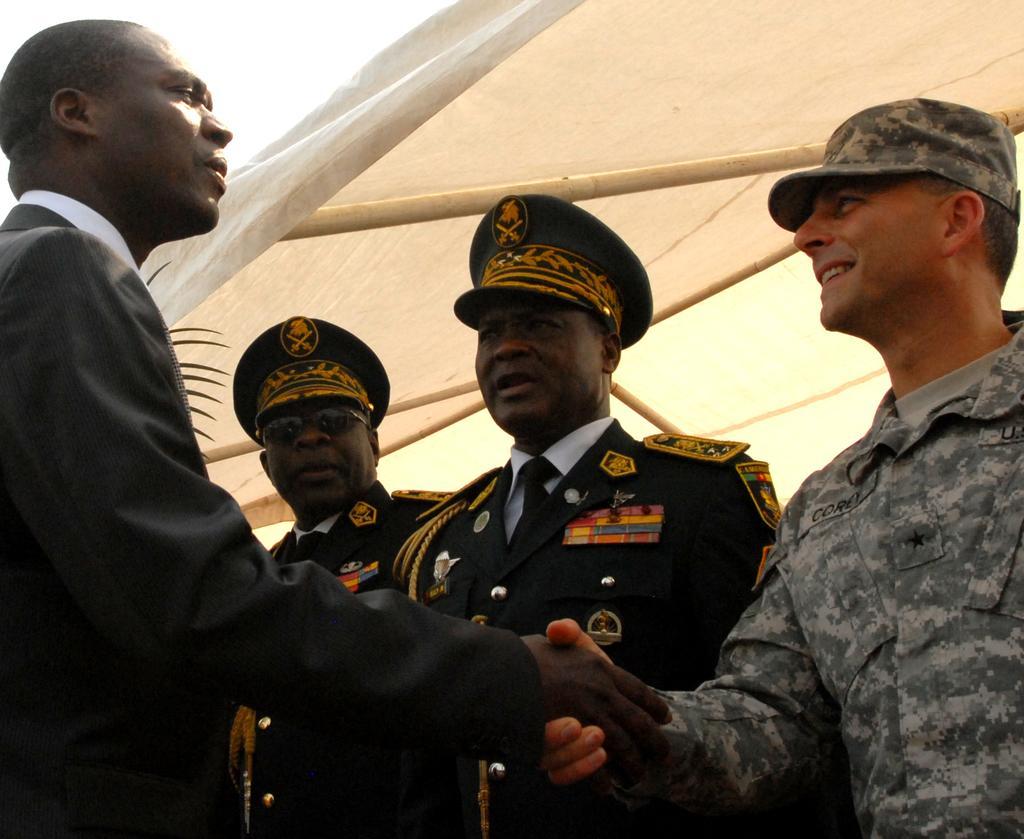Describe this image in one or two sentences. In this picture there are men standing, among them two men shaking hands each other and we can see tent. In the background of the image we can see the sky. 